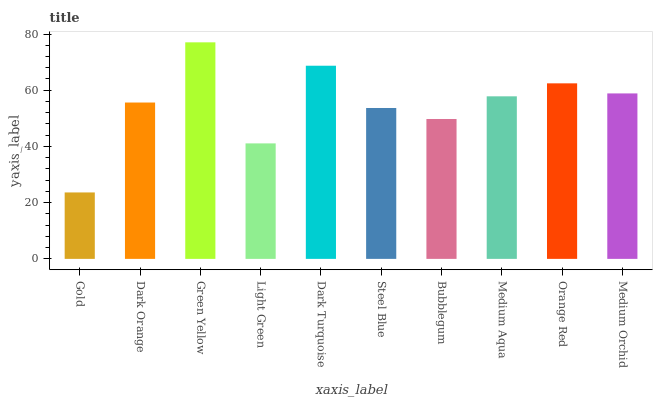Is Gold the minimum?
Answer yes or no. Yes. Is Green Yellow the maximum?
Answer yes or no. Yes. Is Dark Orange the minimum?
Answer yes or no. No. Is Dark Orange the maximum?
Answer yes or no. No. Is Dark Orange greater than Gold?
Answer yes or no. Yes. Is Gold less than Dark Orange?
Answer yes or no. Yes. Is Gold greater than Dark Orange?
Answer yes or no. No. Is Dark Orange less than Gold?
Answer yes or no. No. Is Medium Aqua the high median?
Answer yes or no. Yes. Is Dark Orange the low median?
Answer yes or no. Yes. Is Green Yellow the high median?
Answer yes or no. No. Is Dark Turquoise the low median?
Answer yes or no. No. 